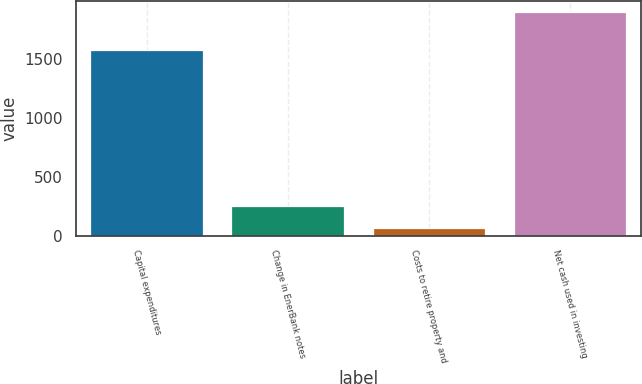<chart> <loc_0><loc_0><loc_500><loc_500><bar_chart><fcel>Capital expenditures<fcel>Change in EnerBank notes<fcel>Costs to retire property and<fcel>Net cash used in investing<nl><fcel>1577<fcel>255<fcel>66<fcel>1898<nl></chart> 